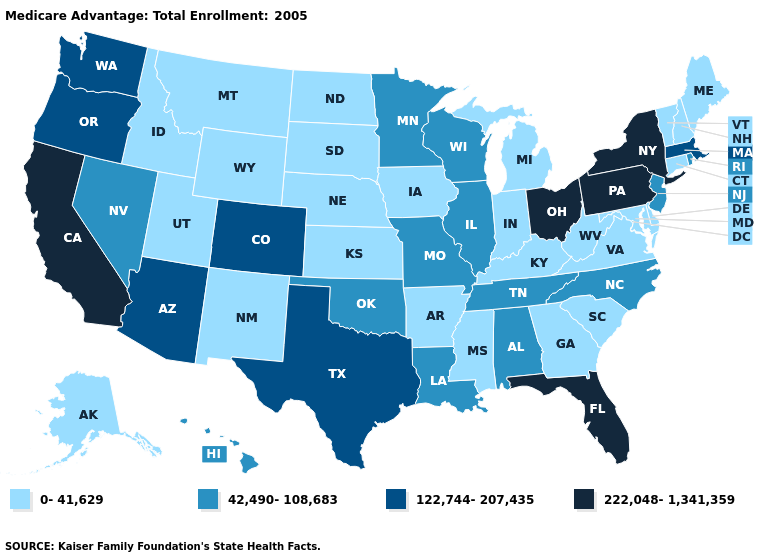Among the states that border Nebraska , does Colorado have the highest value?
Quick response, please. Yes. Name the states that have a value in the range 42,490-108,683?
Write a very short answer. Alabama, Hawaii, Illinois, Louisiana, Minnesota, Missouri, North Carolina, New Jersey, Nevada, Oklahoma, Rhode Island, Tennessee, Wisconsin. What is the value of Massachusetts?
Write a very short answer. 122,744-207,435. Does Vermont have the lowest value in the USA?
Concise answer only. Yes. What is the highest value in the Northeast ?
Quick response, please. 222,048-1,341,359. Does the map have missing data?
Quick response, please. No. Among the states that border New Hampshire , does Vermont have the lowest value?
Quick response, please. Yes. What is the value of Virginia?
Keep it brief. 0-41,629. Which states hav the highest value in the South?
Short answer required. Florida. Among the states that border California , does Nevada have the highest value?
Quick response, please. No. Does California have the highest value in the USA?
Concise answer only. Yes. What is the value of Kansas?
Give a very brief answer. 0-41,629. What is the lowest value in the USA?
Short answer required. 0-41,629. What is the value of Texas?
Be succinct. 122,744-207,435. Which states have the highest value in the USA?
Concise answer only. California, Florida, New York, Ohio, Pennsylvania. 